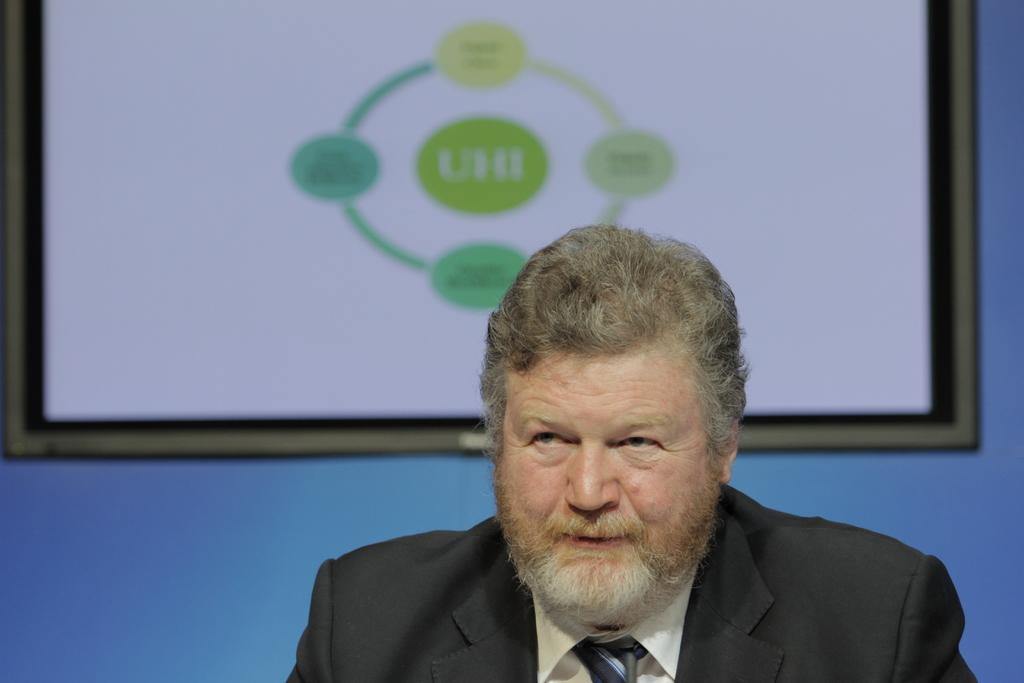Who is present in the image? There is a man in the image. What is the man wearing? The man is wearing a suit. What might the man be doing in the image? The man appears to be speaking. What can be seen in the background of the image? There is a frame in the background of the image. What is the color of the background? The background color is blue. Are there any plantations visible in the image? There are no plantations present in the image. Can you see any hills in the background of the image? There are no hills visible in the image. 